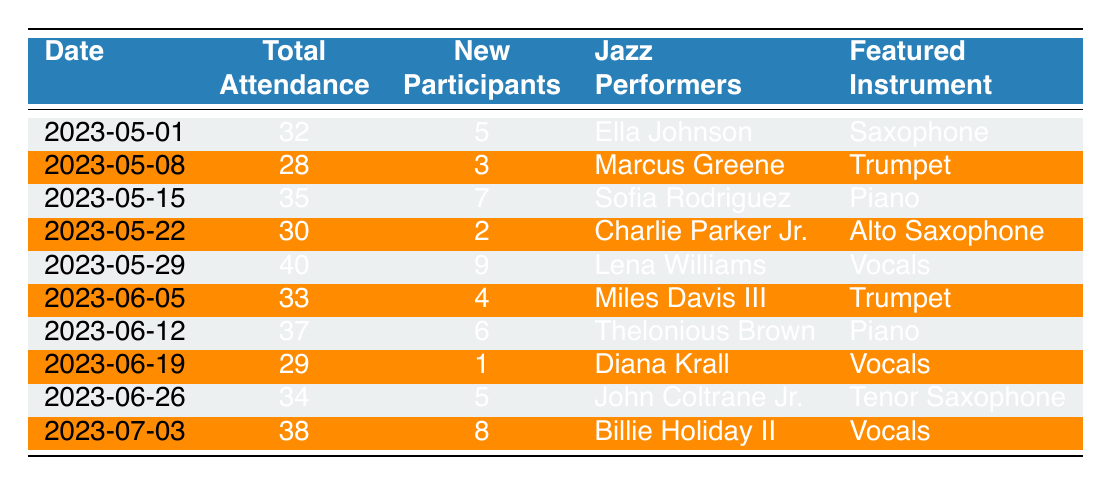What was the date of the session with the highest total attendance? To find the session with the highest total attendance, I need to look at the 'Total Attendance' column and identify the maximum value. The maximum attendance recorded is 40, which occurred on 2023-05-29.
Answer: 2023-05-29 How many new participants attended the jam session on May 15, 2023? I can find the new participants for May 15 by checking the corresponding row for that date in the 'New Participants' column. It shows that there were 7 new participants.
Answer: 7 Is there a jazz performer named "Ella Johnson" in the recordings? Yes, I can confirm if "Ella Johnson" is mentioned by looking in the 'Jazz Performers' column. She is listed in the row for the date 2023-05-01.
Answer: Yes What is the average total attendance over the recorded sessions? To calculate the average, I will sum all values in the 'Total Attendance' column and divide by the number of sessions, which is 10. The total attendance is (32 + 28 + 35 + 30 + 40 + 33 + 37 + 29 + 34 + 38) =  366. Thus, the average attendance is 366/10 = 36.6.
Answer: 36.6 Which featured instrument was played by the performer with the lowest attendance? From the 'Total Attendance' column, the lowest attendance is 28, recorded on 2023-05-08. The corresponding performer is Marcus Greene, who played the trumpet.
Answer: Trumpet How many sessions listed featured vocals as the instrument? I need to go through the 'Featured Instrument' column and count how many sessions have "Vocals" noted. Upon inspection, there are 4 occurrences of "Vocals."
Answer: 4 Did the attendance increase during the last session compared to the session two weeks prior? I need to compare the total attendance for the last session (38 on 2023-07-03) with that of the session two weeks prior (34 on 2023-06-26). Since 38 is greater than 34, attendance did increase.
Answer: Yes What is the difference in new participants between the session on June 12, 2023, and the session on May 1, 2023? I find the new participants for June 12 (6) and for May 1 (5) in their respective rows. The difference is calculated by subtracting the new participants of May 1 from those of June 12: 6 - 5 = 1.
Answer: 1 Which jazz performer had the most new participants in their session? I will look for the maximum value in the 'New Participants' column. The highest is 9, associated with Lena Williams on 2023-05-29.
Answer: Lena Williams 